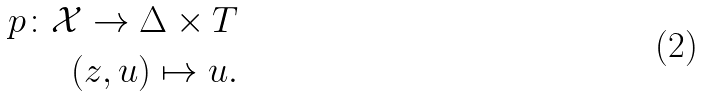Convert formula to latex. <formula><loc_0><loc_0><loc_500><loc_500>p \colon \mathcal { X } \rightarrow \Delta \times T \\ ( z , u ) \mapsto u .</formula> 